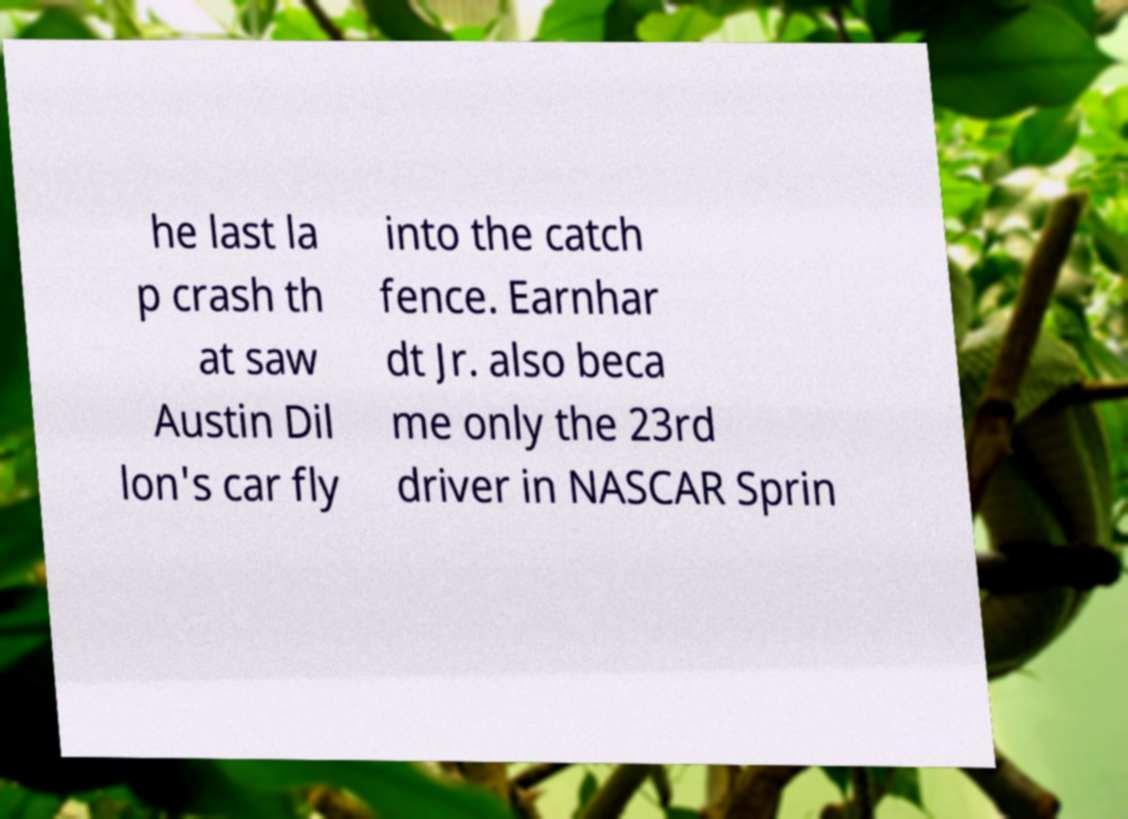There's text embedded in this image that I need extracted. Can you transcribe it verbatim? he last la p crash th at saw Austin Dil lon's car fly into the catch fence. Earnhar dt Jr. also beca me only the 23rd driver in NASCAR Sprin 